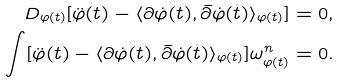Convert formula to latex. <formula><loc_0><loc_0><loc_500><loc_500>D _ { \varphi ( t ) } [ \ddot { \varphi } ( t ) - \langle \partial \dot { \varphi } ( t ) , \bar { \partial } \dot { \varphi } ( t ) \rangle _ { \varphi ( t ) } ] = 0 , \\ \int [ \ddot { \varphi } ( t ) - \langle \partial \dot { \varphi } ( t ) , \bar { \partial } \dot { \varphi } ( t ) \rangle _ { \varphi ( t ) } ] \omega _ { \varphi ( t ) } ^ { n } = 0 .</formula> 